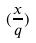Convert formula to latex. <formula><loc_0><loc_0><loc_500><loc_500>( \frac { x } { q } )</formula> 